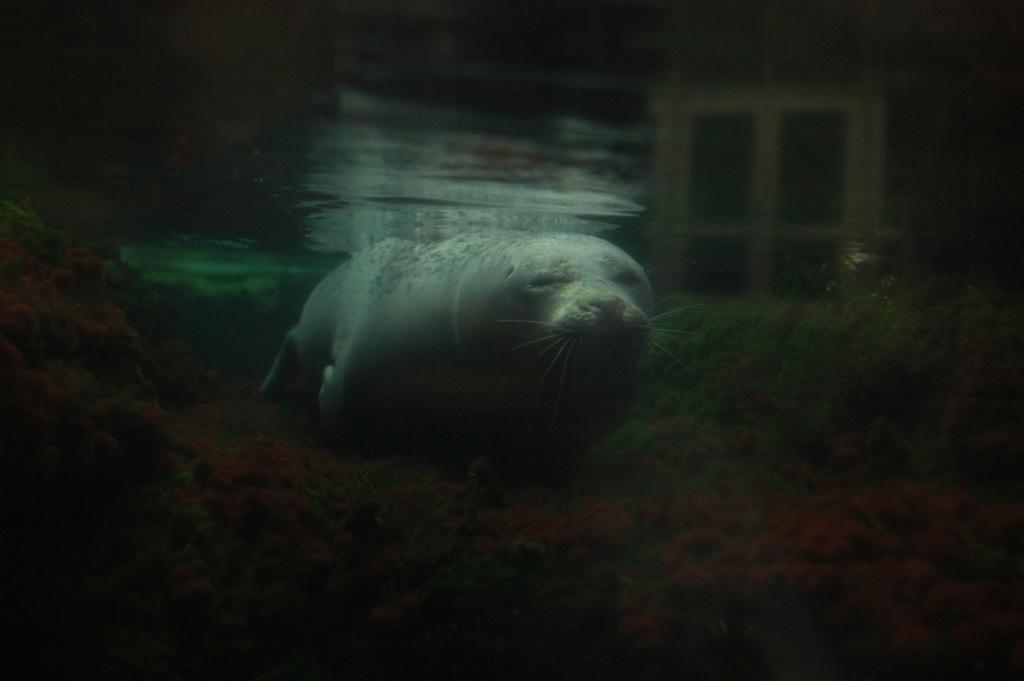Can you describe this image briefly? This image is taken under the water. There is a animal at the center of the image. 